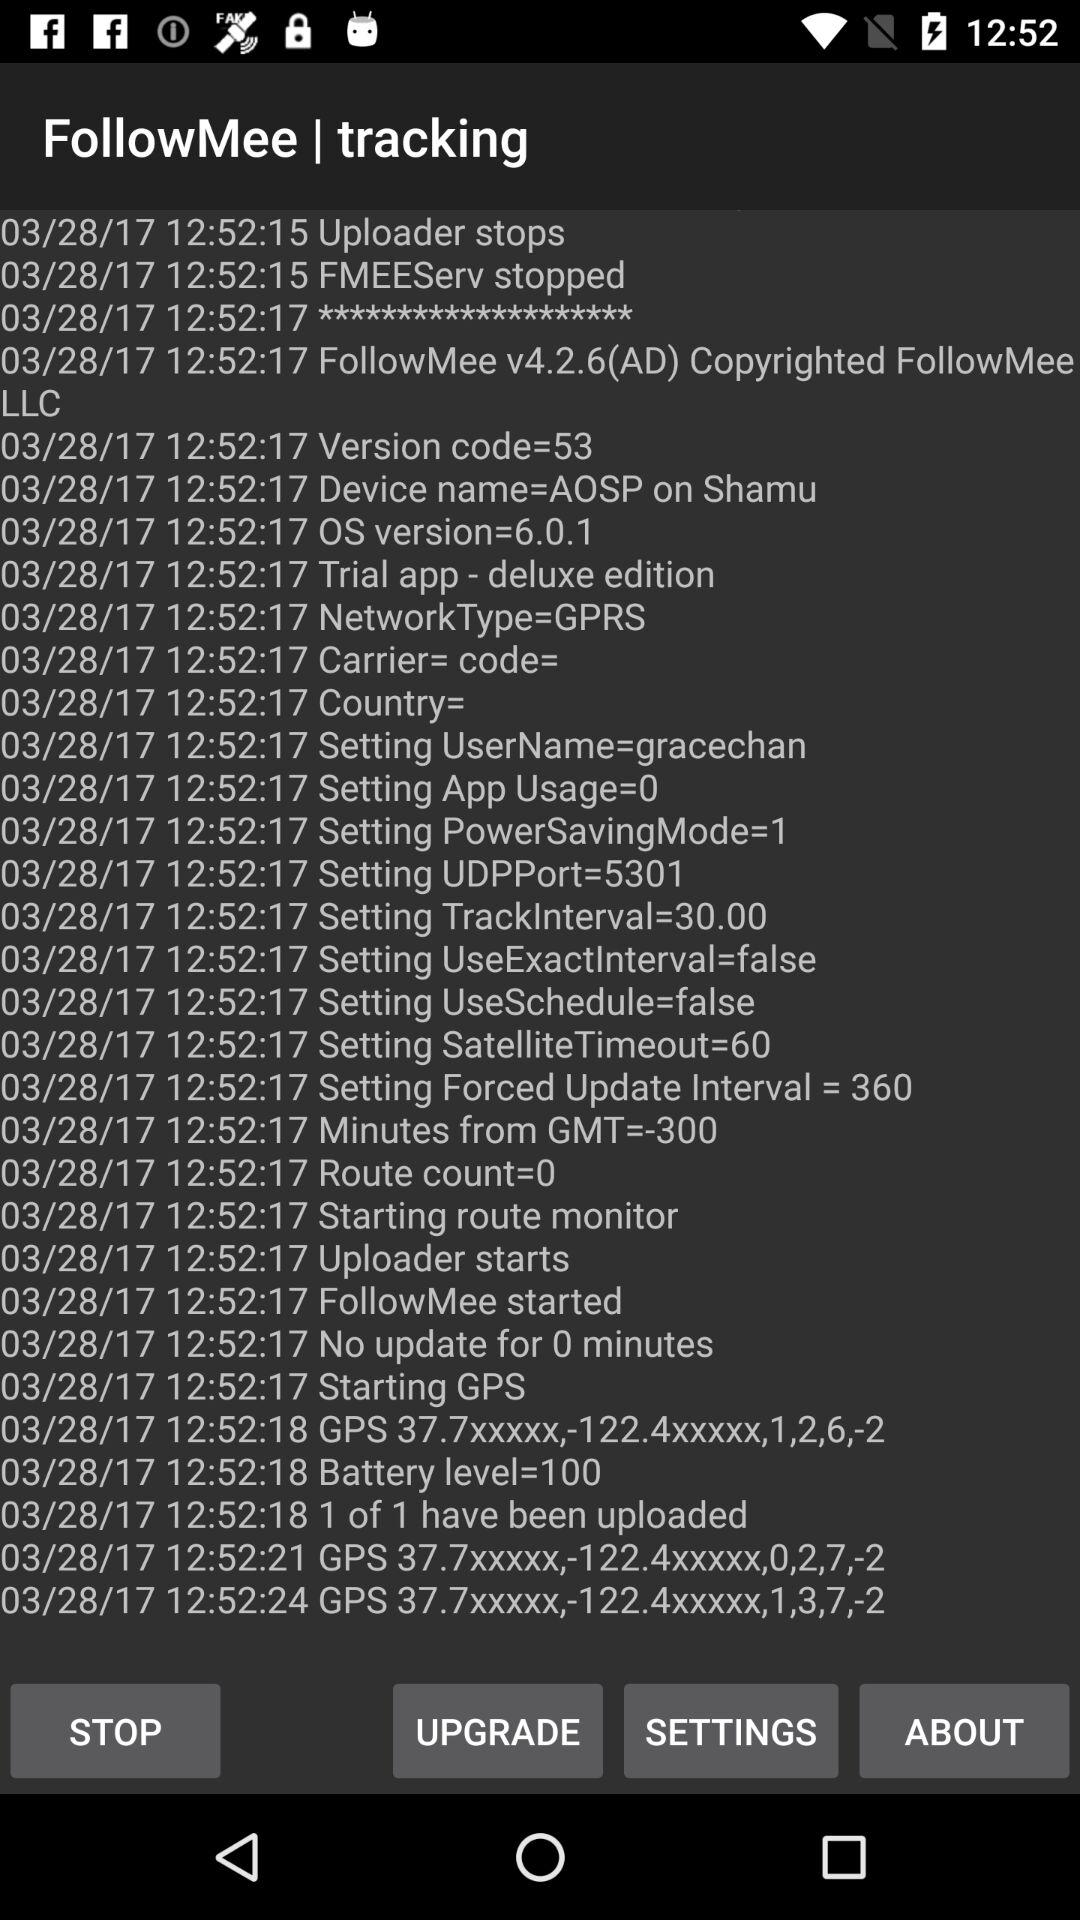What's the username? The user name is Gracechan. 